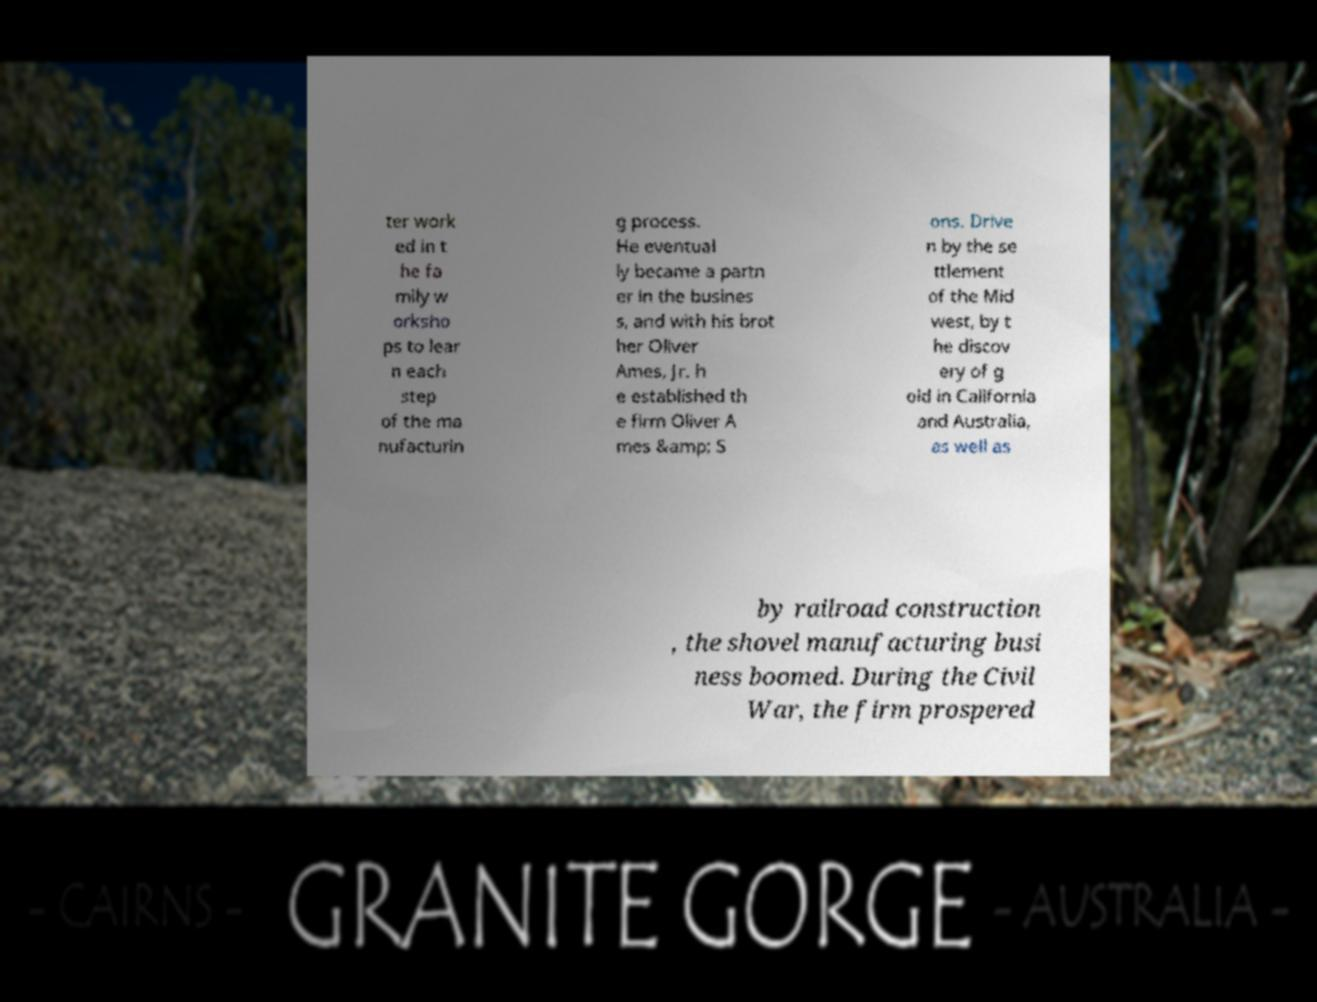Could you assist in decoding the text presented in this image and type it out clearly? ter work ed in t he fa mily w orksho ps to lear n each step of the ma nufacturin g process. He eventual ly became a partn er in the busines s, and with his brot her Oliver Ames, Jr. h e established th e firm Oliver A mes &amp; S ons. Drive n by the se ttlement of the Mid west, by t he discov ery of g old in California and Australia, as well as by railroad construction , the shovel manufacturing busi ness boomed. During the Civil War, the firm prospered 